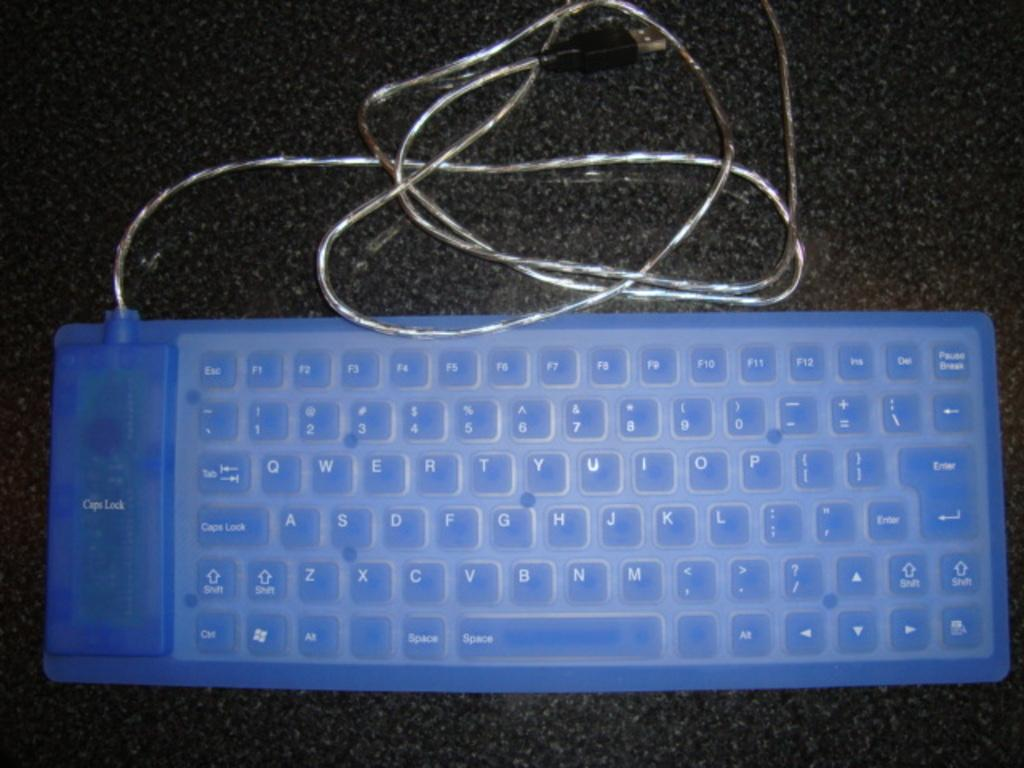<image>
Relay a brief, clear account of the picture shown. A blue keyboard with a giant caps lock key on the left 